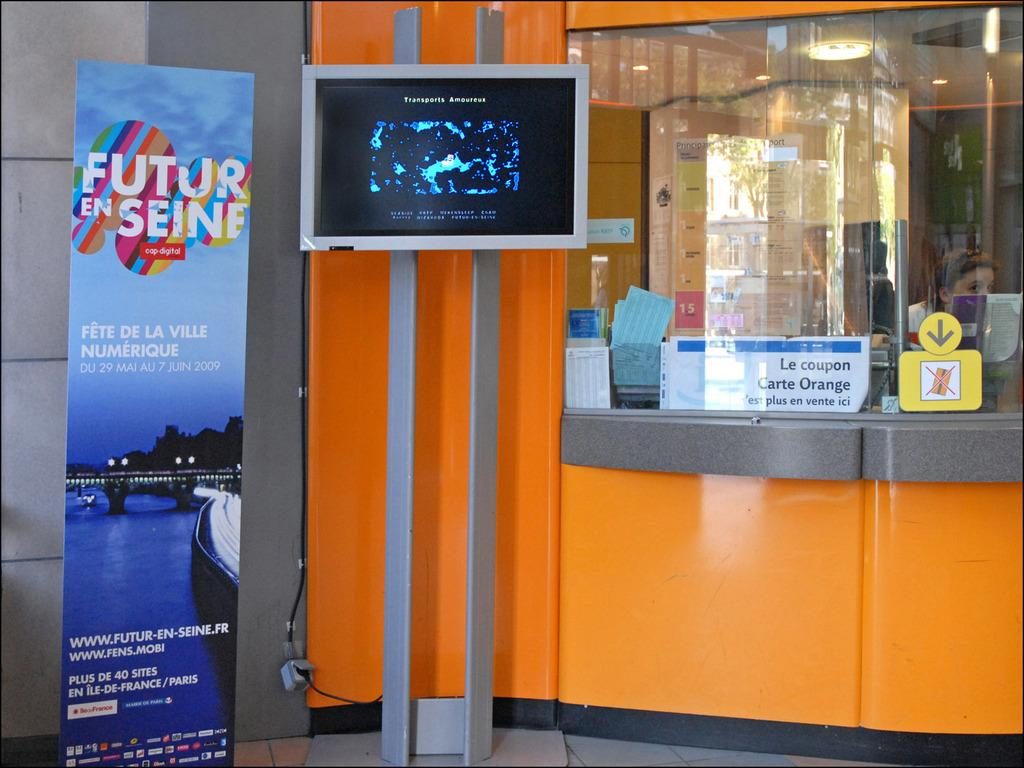<image>
Summarize the visual content of the image. A sign with a sky background and text that says futur en seine. 